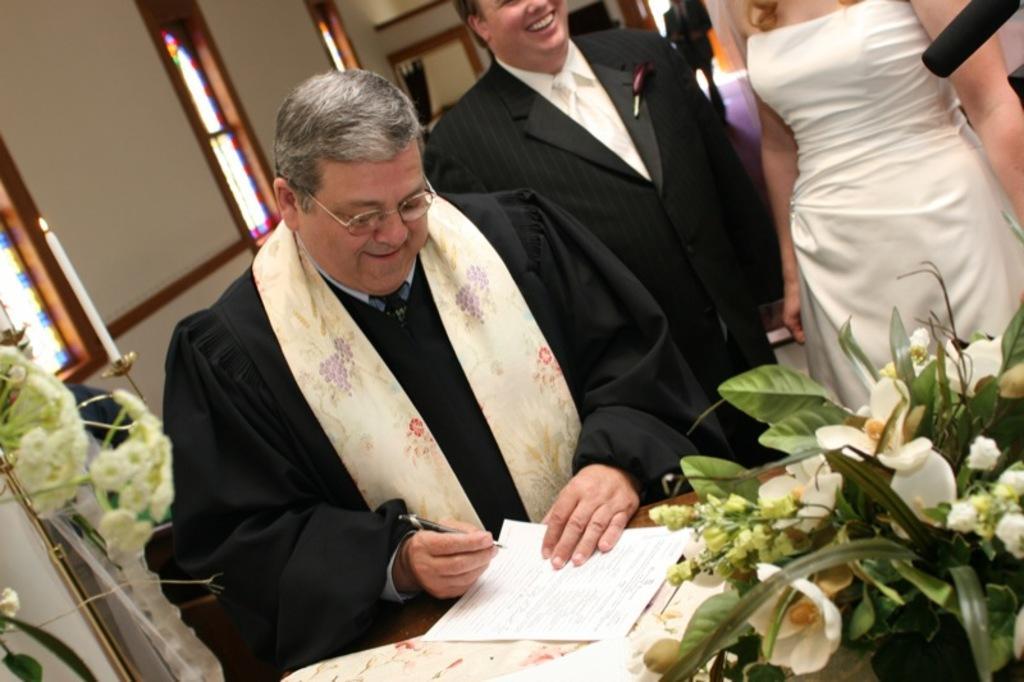How would you summarize this image in a sentence or two? In the image we can see there are two men and a woman wearing clothes. This man is wearing spectacles and holding a paper and pen in his hand. There are flower bookey, window and a wall. 